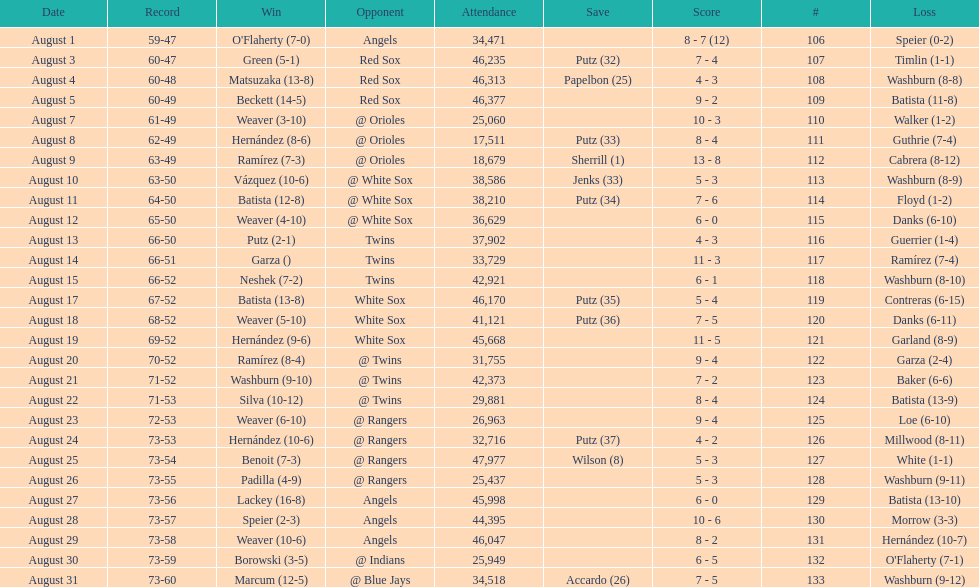Games above 30,000 in attendance 21. 